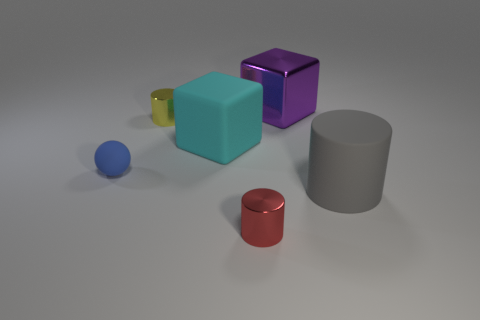There is a large object that is in front of the large object on the left side of the purple shiny block; what is it made of?
Your answer should be very brief. Rubber. How many other big gray objects have the same shape as the big gray rubber thing?
Your answer should be compact. 0. What size is the rubber object left of the big thing that is on the left side of the object in front of the big gray cylinder?
Offer a terse response. Small. How many yellow objects are either tiny cylinders or large blocks?
Offer a very short reply. 1. Do the object that is behind the yellow cylinder and the tiny yellow shiny thing have the same shape?
Provide a short and direct response. No. Are there more purple shiny objects behind the big cylinder than red shiny blocks?
Your answer should be compact. Yes. How many spheres have the same size as the red cylinder?
Offer a very short reply. 1. How many things are blue matte spheres or metal cylinders on the right side of the large cyan object?
Your answer should be compact. 2. There is a shiny object that is in front of the purple metal object and behind the cyan object; what is its color?
Ensure brevity in your answer.  Yellow. Is the purple block the same size as the gray cylinder?
Make the answer very short. Yes. 